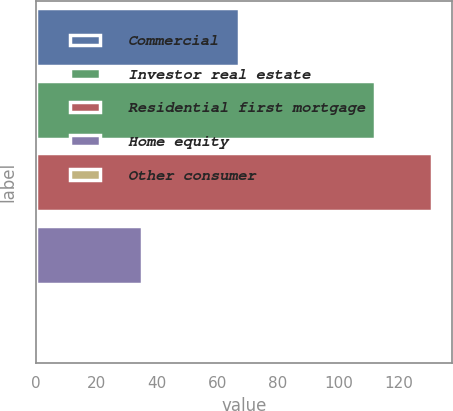Convert chart to OTSL. <chart><loc_0><loc_0><loc_500><loc_500><bar_chart><fcel>Commercial<fcel>Investor real estate<fcel>Residential first mortgage<fcel>Home equity<fcel>Other consumer<nl><fcel>67<fcel>112<fcel>131<fcel>35<fcel>1<nl></chart> 